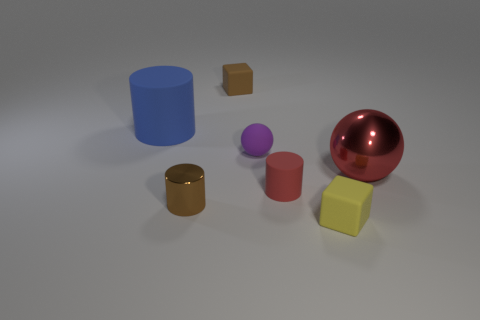Add 3 red metallic balls. How many objects exist? 10 Subtract all spheres. How many objects are left? 5 Subtract all matte things. Subtract all blocks. How many objects are left? 0 Add 3 purple objects. How many purple objects are left? 4 Add 1 red things. How many red things exist? 3 Subtract 1 red cylinders. How many objects are left? 6 